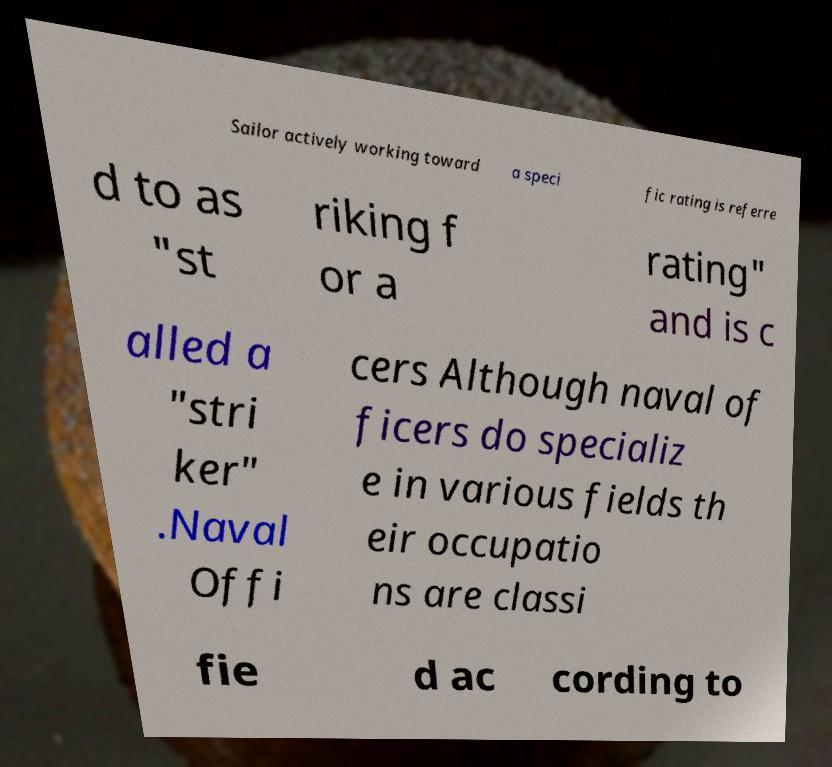For documentation purposes, I need the text within this image transcribed. Could you provide that? Sailor actively working toward a speci fic rating is referre d to as "st riking f or a rating" and is c alled a "stri ker" .Naval Offi cers Although naval of ficers do specializ e in various fields th eir occupatio ns are classi fie d ac cording to 